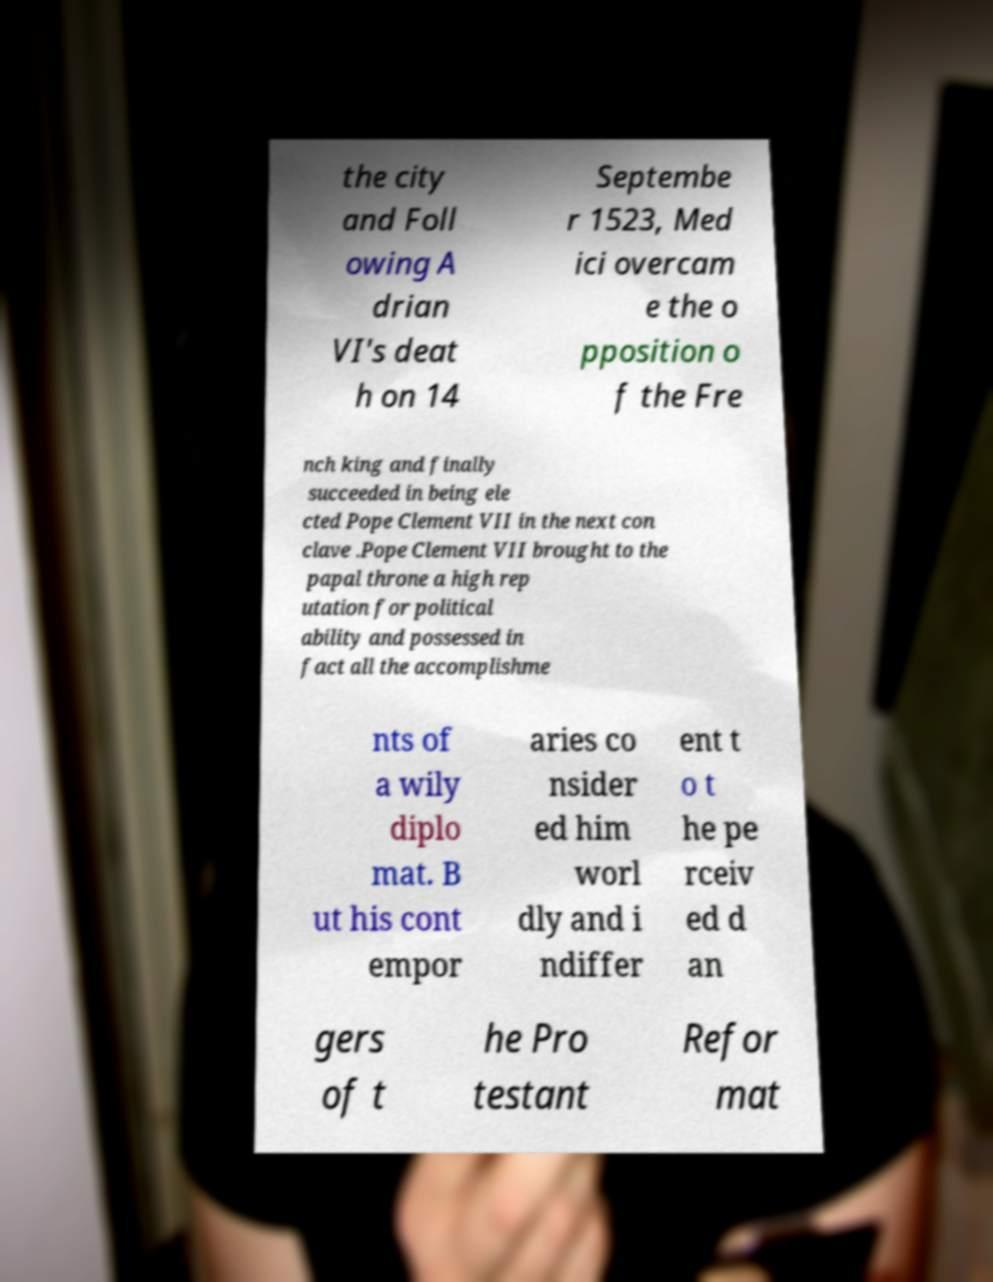What messages or text are displayed in this image? I need them in a readable, typed format. the city and Foll owing A drian VI's deat h on 14 Septembe r 1523, Med ici overcam e the o pposition o f the Fre nch king and finally succeeded in being ele cted Pope Clement VII in the next con clave .Pope Clement VII brought to the papal throne a high rep utation for political ability and possessed in fact all the accomplishme nts of a wily diplo mat. B ut his cont empor aries co nsider ed him worl dly and i ndiffer ent t o t he pe rceiv ed d an gers of t he Pro testant Refor mat 